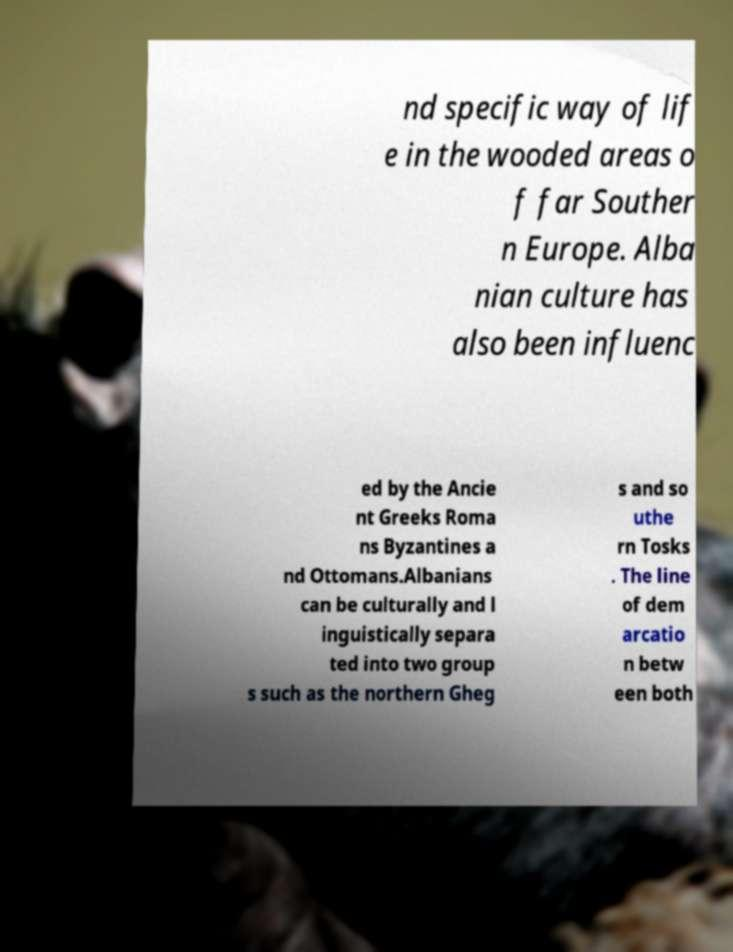I need the written content from this picture converted into text. Can you do that? nd specific way of lif e in the wooded areas o f far Souther n Europe. Alba nian culture has also been influenc ed by the Ancie nt Greeks Roma ns Byzantines a nd Ottomans.Albanians can be culturally and l inguistically separa ted into two group s such as the northern Gheg s and so uthe rn Tosks . The line of dem arcatio n betw een both 